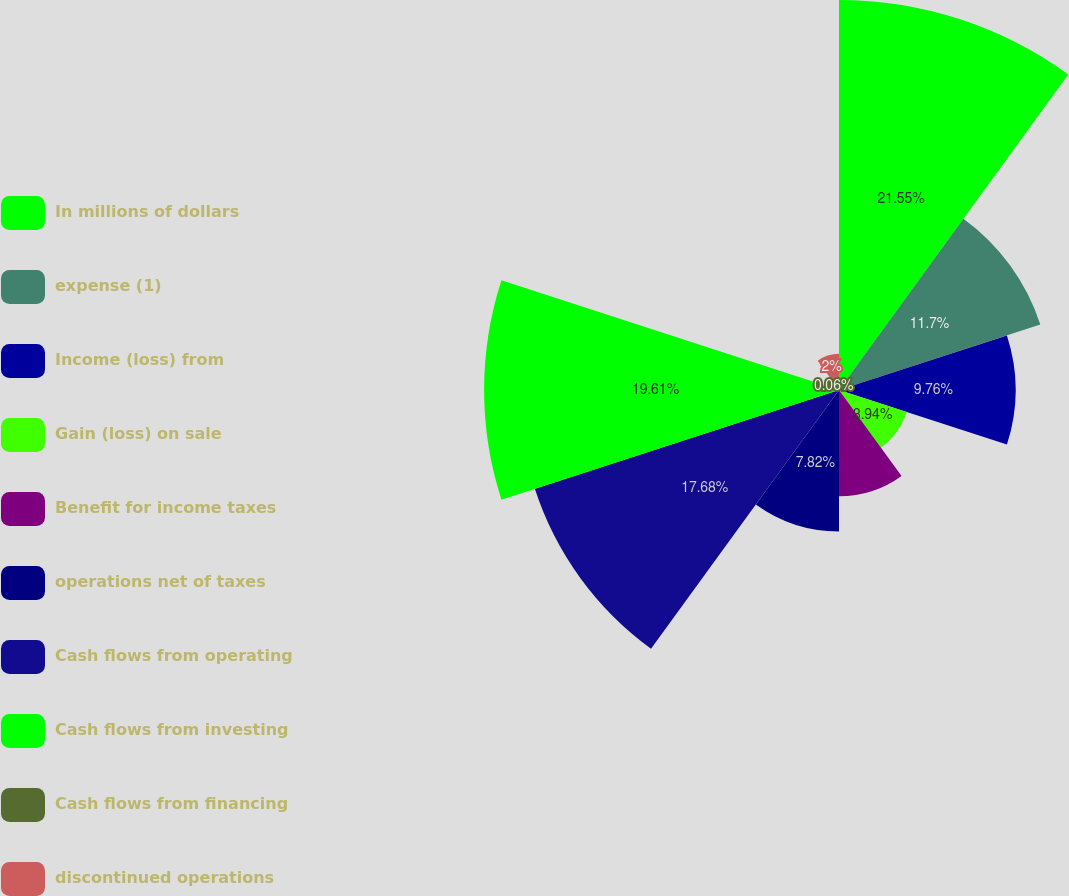Convert chart to OTSL. <chart><loc_0><loc_0><loc_500><loc_500><pie_chart><fcel>In millions of dollars<fcel>expense (1)<fcel>Income (loss) from<fcel>Gain (loss) on sale<fcel>Benefit for income taxes<fcel>operations net of taxes<fcel>Cash flows from operating<fcel>Cash flows from investing<fcel>Cash flows from financing<fcel>discontinued operations<nl><fcel>21.56%<fcel>11.7%<fcel>9.76%<fcel>3.94%<fcel>5.88%<fcel>7.82%<fcel>17.68%<fcel>19.62%<fcel>0.06%<fcel>2.0%<nl></chart> 